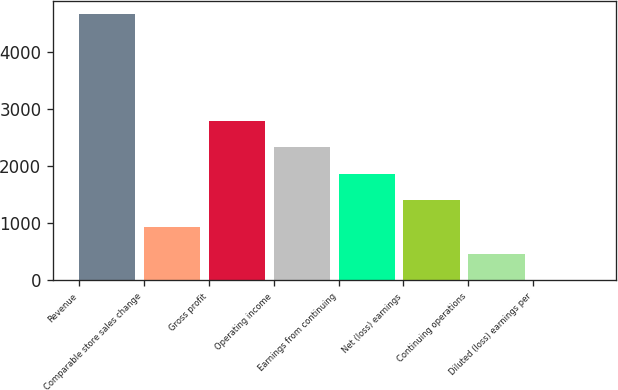Convert chart. <chart><loc_0><loc_0><loc_500><loc_500><bar_chart><fcel>Revenue<fcel>Comparable store sales change<fcel>Gross profit<fcel>Operating income<fcel>Earnings from continuing<fcel>Net (loss) earnings<fcel>Continuing operations<fcel>Diluted (loss) earnings per<nl><fcel>4668<fcel>933.66<fcel>2800.82<fcel>2334.03<fcel>1867.24<fcel>1400.45<fcel>466.87<fcel>0.08<nl></chart> 